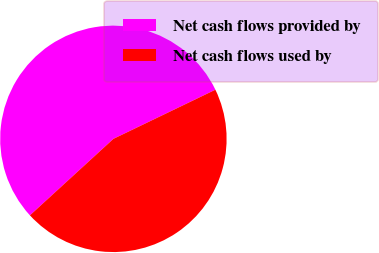Convert chart. <chart><loc_0><loc_0><loc_500><loc_500><pie_chart><fcel>Net cash flows provided by<fcel>Net cash flows used by<nl><fcel>54.66%<fcel>45.34%<nl></chart> 